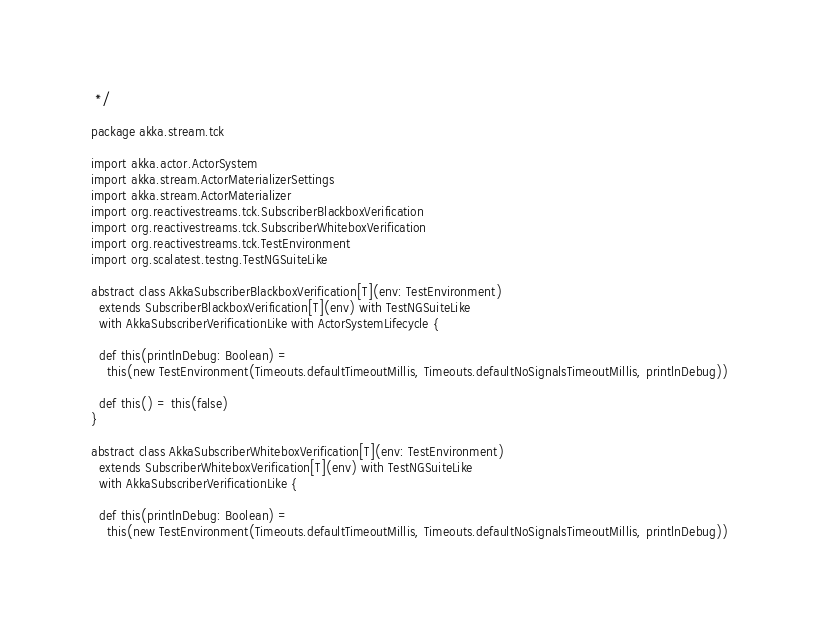<code> <loc_0><loc_0><loc_500><loc_500><_Scala_> */

package akka.stream.tck

import akka.actor.ActorSystem
import akka.stream.ActorMaterializerSettings
import akka.stream.ActorMaterializer
import org.reactivestreams.tck.SubscriberBlackboxVerification
import org.reactivestreams.tck.SubscriberWhiteboxVerification
import org.reactivestreams.tck.TestEnvironment
import org.scalatest.testng.TestNGSuiteLike

abstract class AkkaSubscriberBlackboxVerification[T](env: TestEnvironment)
  extends SubscriberBlackboxVerification[T](env) with TestNGSuiteLike
  with AkkaSubscriberVerificationLike with ActorSystemLifecycle {

  def this(printlnDebug: Boolean) =
    this(new TestEnvironment(Timeouts.defaultTimeoutMillis, Timeouts.defaultNoSignalsTimeoutMillis, printlnDebug))

  def this() = this(false)
}

abstract class AkkaSubscriberWhiteboxVerification[T](env: TestEnvironment)
  extends SubscriberWhiteboxVerification[T](env) with TestNGSuiteLike
  with AkkaSubscriberVerificationLike {

  def this(printlnDebug: Boolean) =
    this(new TestEnvironment(Timeouts.defaultTimeoutMillis, Timeouts.defaultNoSignalsTimeoutMillis, printlnDebug))
</code> 